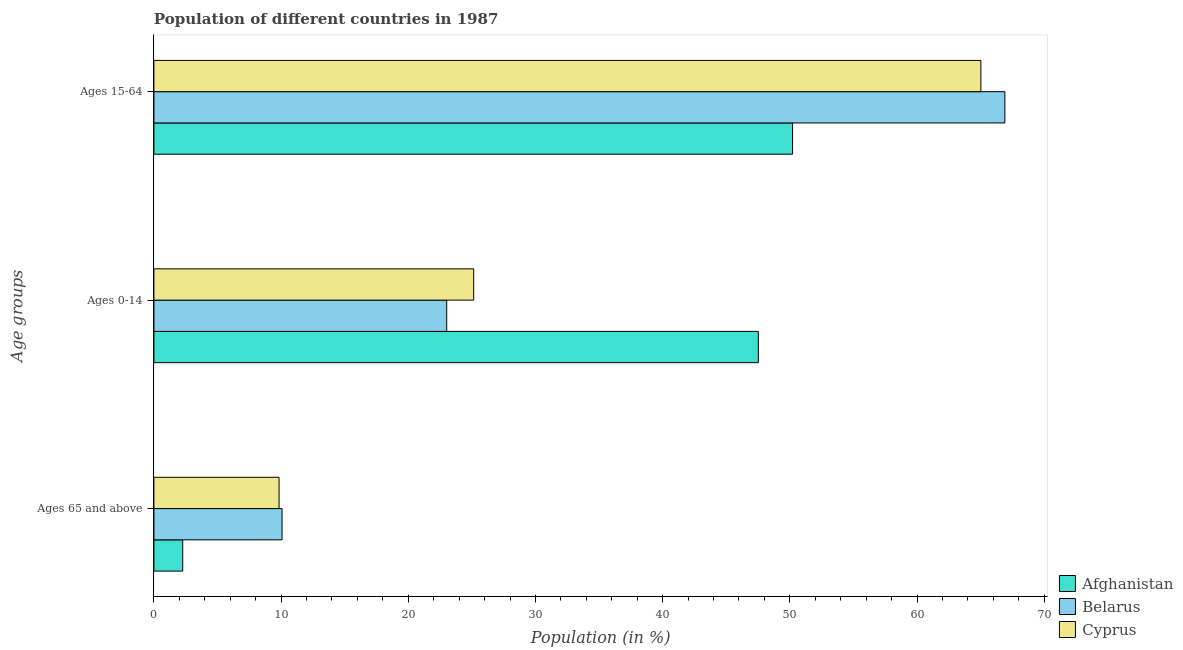How many groups of bars are there?
Make the answer very short. 3. Are the number of bars per tick equal to the number of legend labels?
Give a very brief answer. Yes. How many bars are there on the 3rd tick from the top?
Your answer should be compact. 3. What is the label of the 2nd group of bars from the top?
Offer a very short reply. Ages 0-14. What is the percentage of population within the age-group 0-14 in Belarus?
Your response must be concise. 23.02. Across all countries, what is the maximum percentage of population within the age-group 15-64?
Your answer should be compact. 66.91. Across all countries, what is the minimum percentage of population within the age-group of 65 and above?
Offer a terse response. 2.26. In which country was the percentage of population within the age-group of 65 and above maximum?
Make the answer very short. Belarus. In which country was the percentage of population within the age-group 0-14 minimum?
Provide a short and direct response. Belarus. What is the total percentage of population within the age-group 15-64 in the graph?
Offer a terse response. 182.14. What is the difference between the percentage of population within the age-group 15-64 in Belarus and that in Cyprus?
Make the answer very short. 1.89. What is the difference between the percentage of population within the age-group 15-64 in Cyprus and the percentage of population within the age-group 0-14 in Afghanistan?
Offer a very short reply. 17.5. What is the average percentage of population within the age-group 15-64 per country?
Offer a terse response. 60.71. What is the difference between the percentage of population within the age-group of 65 and above and percentage of population within the age-group 0-14 in Afghanistan?
Offer a terse response. -45.26. In how many countries, is the percentage of population within the age-group 15-64 greater than 30 %?
Provide a short and direct response. 3. What is the ratio of the percentage of population within the age-group of 65 and above in Belarus to that in Cyprus?
Provide a short and direct response. 1.02. Is the percentage of population within the age-group 0-14 in Afghanistan less than that in Belarus?
Ensure brevity in your answer.  No. What is the difference between the highest and the second highest percentage of population within the age-group 15-64?
Make the answer very short. 1.89. What is the difference between the highest and the lowest percentage of population within the age-group 0-14?
Your answer should be very brief. 24.5. In how many countries, is the percentage of population within the age-group 15-64 greater than the average percentage of population within the age-group 15-64 taken over all countries?
Provide a short and direct response. 2. Is the sum of the percentage of population within the age-group 0-14 in Cyprus and Afghanistan greater than the maximum percentage of population within the age-group of 65 and above across all countries?
Keep it short and to the point. Yes. What does the 3rd bar from the top in Ages 65 and above represents?
Your answer should be compact. Afghanistan. What does the 1st bar from the bottom in Ages 15-64 represents?
Keep it short and to the point. Afghanistan. Is it the case that in every country, the sum of the percentage of population within the age-group of 65 and above and percentage of population within the age-group 0-14 is greater than the percentage of population within the age-group 15-64?
Provide a short and direct response. No. Are all the bars in the graph horizontal?
Provide a short and direct response. Yes. Are the values on the major ticks of X-axis written in scientific E-notation?
Your answer should be very brief. No. Does the graph contain any zero values?
Offer a very short reply. No. Where does the legend appear in the graph?
Ensure brevity in your answer.  Bottom right. How many legend labels are there?
Your answer should be very brief. 3. How are the legend labels stacked?
Offer a terse response. Vertical. What is the title of the graph?
Make the answer very short. Population of different countries in 1987. Does "Madagascar" appear as one of the legend labels in the graph?
Give a very brief answer. No. What is the label or title of the X-axis?
Make the answer very short. Population (in %). What is the label or title of the Y-axis?
Your response must be concise. Age groups. What is the Population (in %) in Afghanistan in Ages 65 and above?
Keep it short and to the point. 2.26. What is the Population (in %) of Belarus in Ages 65 and above?
Your answer should be very brief. 10.07. What is the Population (in %) in Cyprus in Ages 65 and above?
Your answer should be very brief. 9.84. What is the Population (in %) of Afghanistan in Ages 0-14?
Offer a very short reply. 47.52. What is the Population (in %) of Belarus in Ages 0-14?
Keep it short and to the point. 23.02. What is the Population (in %) in Cyprus in Ages 0-14?
Give a very brief answer. 25.14. What is the Population (in %) in Afghanistan in Ages 15-64?
Keep it short and to the point. 50.21. What is the Population (in %) in Belarus in Ages 15-64?
Your answer should be very brief. 66.91. What is the Population (in %) in Cyprus in Ages 15-64?
Keep it short and to the point. 65.02. Across all Age groups, what is the maximum Population (in %) in Afghanistan?
Your response must be concise. 50.21. Across all Age groups, what is the maximum Population (in %) in Belarus?
Ensure brevity in your answer.  66.91. Across all Age groups, what is the maximum Population (in %) of Cyprus?
Offer a terse response. 65.02. Across all Age groups, what is the minimum Population (in %) in Afghanistan?
Make the answer very short. 2.26. Across all Age groups, what is the minimum Population (in %) in Belarus?
Offer a very short reply. 10.07. Across all Age groups, what is the minimum Population (in %) of Cyprus?
Provide a succinct answer. 9.84. What is the total Population (in %) in Cyprus in the graph?
Provide a short and direct response. 100. What is the difference between the Population (in %) of Afghanistan in Ages 65 and above and that in Ages 0-14?
Provide a succinct answer. -45.26. What is the difference between the Population (in %) of Belarus in Ages 65 and above and that in Ages 0-14?
Provide a succinct answer. -12.95. What is the difference between the Population (in %) in Cyprus in Ages 65 and above and that in Ages 0-14?
Your response must be concise. -15.3. What is the difference between the Population (in %) in Afghanistan in Ages 65 and above and that in Ages 15-64?
Your response must be concise. -47.95. What is the difference between the Population (in %) in Belarus in Ages 65 and above and that in Ages 15-64?
Offer a very short reply. -56.83. What is the difference between the Population (in %) in Cyprus in Ages 65 and above and that in Ages 15-64?
Provide a short and direct response. -55.18. What is the difference between the Population (in %) in Afghanistan in Ages 0-14 and that in Ages 15-64?
Your answer should be compact. -2.69. What is the difference between the Population (in %) in Belarus in Ages 0-14 and that in Ages 15-64?
Ensure brevity in your answer.  -43.89. What is the difference between the Population (in %) of Cyprus in Ages 0-14 and that in Ages 15-64?
Your answer should be very brief. -39.88. What is the difference between the Population (in %) of Afghanistan in Ages 65 and above and the Population (in %) of Belarus in Ages 0-14?
Ensure brevity in your answer.  -20.76. What is the difference between the Population (in %) of Afghanistan in Ages 65 and above and the Population (in %) of Cyprus in Ages 0-14?
Provide a short and direct response. -22.88. What is the difference between the Population (in %) in Belarus in Ages 65 and above and the Population (in %) in Cyprus in Ages 0-14?
Keep it short and to the point. -15.07. What is the difference between the Population (in %) of Afghanistan in Ages 65 and above and the Population (in %) of Belarus in Ages 15-64?
Keep it short and to the point. -64.64. What is the difference between the Population (in %) in Afghanistan in Ages 65 and above and the Population (in %) in Cyprus in Ages 15-64?
Give a very brief answer. -62.76. What is the difference between the Population (in %) of Belarus in Ages 65 and above and the Population (in %) of Cyprus in Ages 15-64?
Keep it short and to the point. -54.95. What is the difference between the Population (in %) in Afghanistan in Ages 0-14 and the Population (in %) in Belarus in Ages 15-64?
Give a very brief answer. -19.38. What is the difference between the Population (in %) of Afghanistan in Ages 0-14 and the Population (in %) of Cyprus in Ages 15-64?
Your answer should be compact. -17.5. What is the difference between the Population (in %) in Belarus in Ages 0-14 and the Population (in %) in Cyprus in Ages 15-64?
Offer a very short reply. -42. What is the average Population (in %) of Afghanistan per Age groups?
Give a very brief answer. 33.33. What is the average Population (in %) of Belarus per Age groups?
Keep it short and to the point. 33.33. What is the average Population (in %) of Cyprus per Age groups?
Offer a very short reply. 33.33. What is the difference between the Population (in %) in Afghanistan and Population (in %) in Belarus in Ages 65 and above?
Provide a short and direct response. -7.81. What is the difference between the Population (in %) of Afghanistan and Population (in %) of Cyprus in Ages 65 and above?
Your answer should be compact. -7.58. What is the difference between the Population (in %) of Belarus and Population (in %) of Cyprus in Ages 65 and above?
Give a very brief answer. 0.23. What is the difference between the Population (in %) of Afghanistan and Population (in %) of Belarus in Ages 0-14?
Provide a succinct answer. 24.5. What is the difference between the Population (in %) of Afghanistan and Population (in %) of Cyprus in Ages 0-14?
Ensure brevity in your answer.  22.38. What is the difference between the Population (in %) of Belarus and Population (in %) of Cyprus in Ages 0-14?
Provide a short and direct response. -2.12. What is the difference between the Population (in %) of Afghanistan and Population (in %) of Belarus in Ages 15-64?
Provide a succinct answer. -16.69. What is the difference between the Population (in %) in Afghanistan and Population (in %) in Cyprus in Ages 15-64?
Offer a very short reply. -14.81. What is the difference between the Population (in %) of Belarus and Population (in %) of Cyprus in Ages 15-64?
Offer a very short reply. 1.89. What is the ratio of the Population (in %) of Afghanistan in Ages 65 and above to that in Ages 0-14?
Keep it short and to the point. 0.05. What is the ratio of the Population (in %) in Belarus in Ages 65 and above to that in Ages 0-14?
Your answer should be compact. 0.44. What is the ratio of the Population (in %) of Cyprus in Ages 65 and above to that in Ages 0-14?
Provide a short and direct response. 0.39. What is the ratio of the Population (in %) of Afghanistan in Ages 65 and above to that in Ages 15-64?
Your response must be concise. 0.05. What is the ratio of the Population (in %) of Belarus in Ages 65 and above to that in Ages 15-64?
Make the answer very short. 0.15. What is the ratio of the Population (in %) of Cyprus in Ages 65 and above to that in Ages 15-64?
Keep it short and to the point. 0.15. What is the ratio of the Population (in %) in Afghanistan in Ages 0-14 to that in Ages 15-64?
Your answer should be very brief. 0.95. What is the ratio of the Population (in %) in Belarus in Ages 0-14 to that in Ages 15-64?
Offer a terse response. 0.34. What is the ratio of the Population (in %) of Cyprus in Ages 0-14 to that in Ages 15-64?
Provide a short and direct response. 0.39. What is the difference between the highest and the second highest Population (in %) in Afghanistan?
Make the answer very short. 2.69. What is the difference between the highest and the second highest Population (in %) of Belarus?
Keep it short and to the point. 43.89. What is the difference between the highest and the second highest Population (in %) in Cyprus?
Make the answer very short. 39.88. What is the difference between the highest and the lowest Population (in %) in Afghanistan?
Make the answer very short. 47.95. What is the difference between the highest and the lowest Population (in %) in Belarus?
Offer a terse response. 56.83. What is the difference between the highest and the lowest Population (in %) of Cyprus?
Make the answer very short. 55.18. 